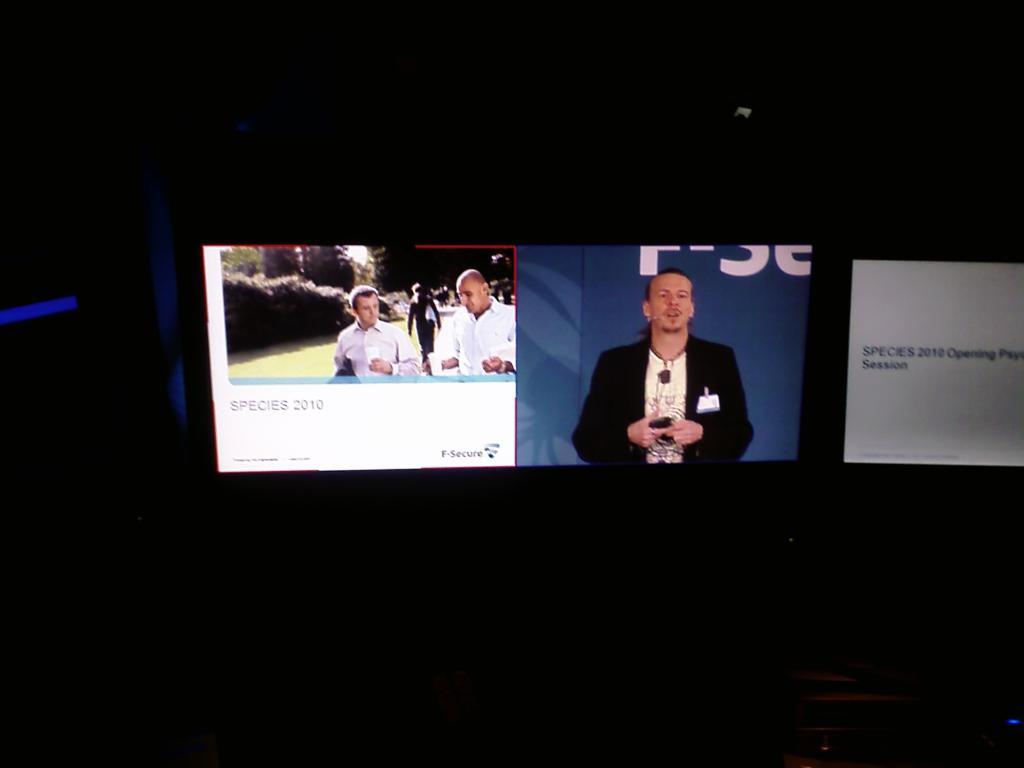<image>
Offer a succinct explanation of the picture presented. A television has a video with the title Species 2010 on the screen. 